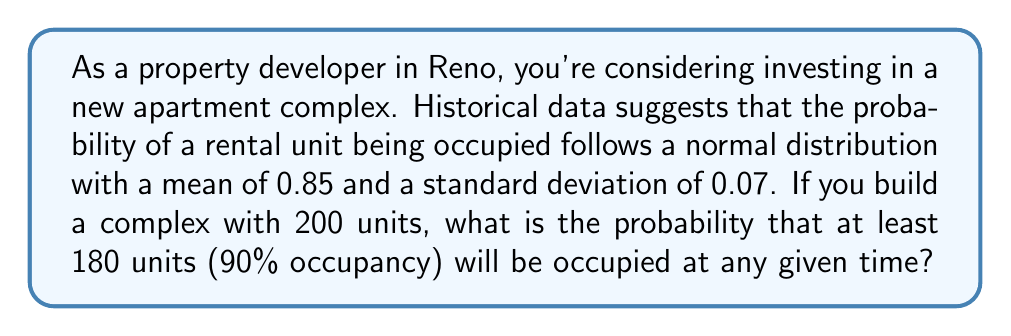Solve this math problem. Let's approach this step-by-step:

1) We're dealing with a normal distribution where:
   $\mu = 0.85$ (mean occupancy rate)
   $\sigma = 0.07$ (standard deviation)
   $n = 200$ (number of units)

2) We want to find $P(X \geq 180)$, where $X$ is the number of occupied units.

3) First, we need to convert this to a standard normal distribution (z-score):

   $z = \frac{X - n\mu}{\sqrt{n\sigma^2}}$

4) Substituting our values:

   $z = \frac{180 - (200 * 0.85)}{\sqrt{200 * 0.07^2}}$

5) Simplify:

   $z = \frac{180 - 170}{\sqrt{200 * 0.0049}} = \frac{10}{\sqrt{0.98}} = \frac{10}{0.99} \approx 10.10$

6) Now we need to find $P(Z \geq 10.10)$ in the standard normal distribution.

7) Using a standard normal table or calculator, we find:

   $P(Z \geq 10.10) \approx 0$

8) Therefore, the probability of having at least 180 units occupied is essentially 0.

This extremely low probability suggests that achieving 90% occupancy is highly unlikely given the historical data. As a property developer, this indicates a significant risk of oversaturation in the Reno rental market for this particular investment.
Answer: $\approx 0$ 